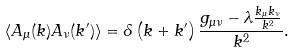<formula> <loc_0><loc_0><loc_500><loc_500>\left \langle A _ { \mu } ( k ) A _ { \nu } ( k ^ { \prime } ) \right \rangle = \delta \left ( k + k ^ { \prime } \right ) { \frac { g _ { \mu \nu } - \lambda { \frac { k _ { \mu } k _ { \nu } } { k ^ { 2 } } } } { k ^ { 2 } } } .</formula> 